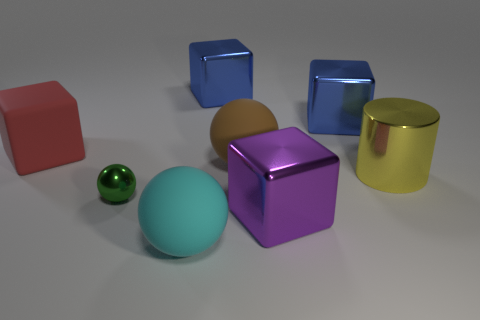There is a big blue object that is to the left of the large brown ball; what shape is it?
Your answer should be very brief. Cube. What is the material of the large brown ball?
Offer a terse response. Rubber. There is a matte block that is the same size as the purple thing; what is its color?
Make the answer very short. Red. Is the shape of the big yellow object the same as the big red thing?
Keep it short and to the point. No. The object that is to the left of the cyan matte ball and behind the large yellow cylinder is made of what material?
Your response must be concise. Rubber. The green metallic sphere is what size?
Your answer should be compact. Small. There is another matte object that is the same shape as the brown matte thing; what color is it?
Give a very brief answer. Cyan. Are there any other things that are the same color as the tiny metallic object?
Provide a succinct answer. No. Do the rubber thing that is on the left side of the cyan rubber object and the metal thing in front of the small green ball have the same size?
Offer a very short reply. Yes. Are there an equal number of matte cubes right of the red thing and small green balls behind the yellow cylinder?
Make the answer very short. Yes. 